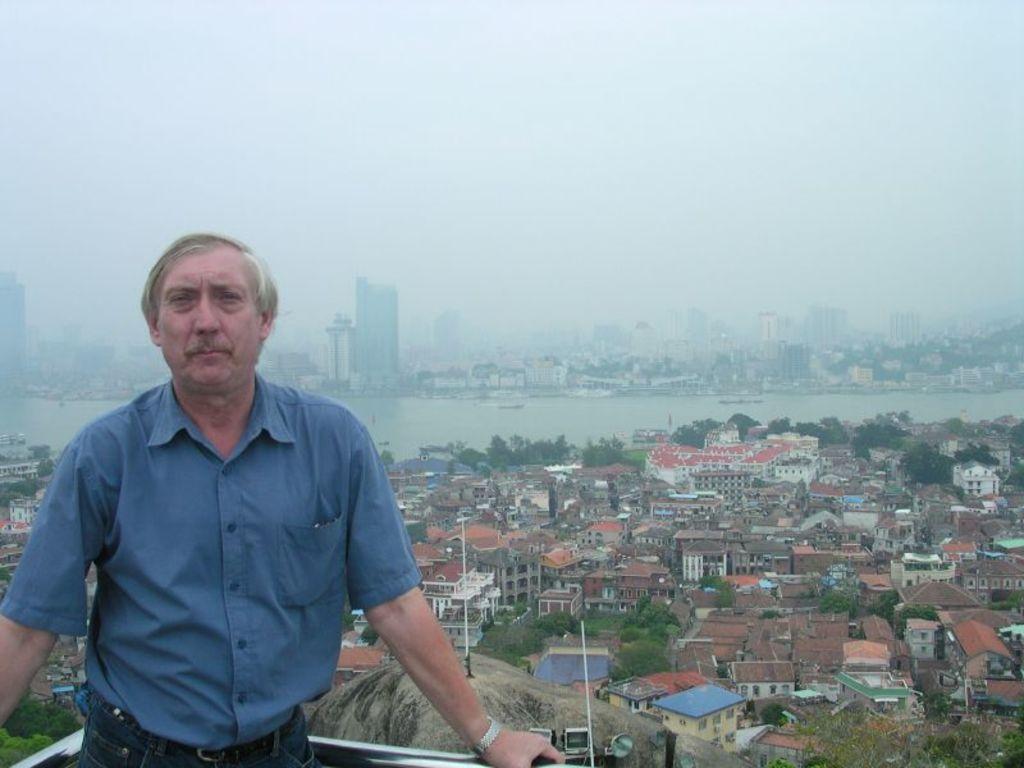In one or two sentences, can you explain what this image depicts? In this image, on the left side, we can see a man wearing a blue color shirt is standing. In the background, we can see some houses, buildings, trees. In the background, we can also see water in a lake. At the top, we can see a sky. 